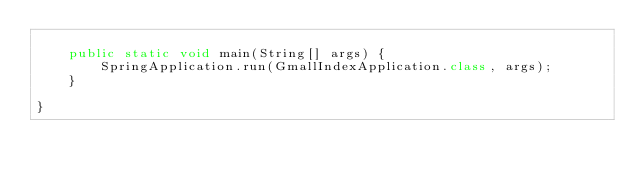<code> <loc_0><loc_0><loc_500><loc_500><_Java_>
	public static void main(String[] args) {
		SpringApplication.run(GmallIndexApplication.class, args);
	}

}
</code> 